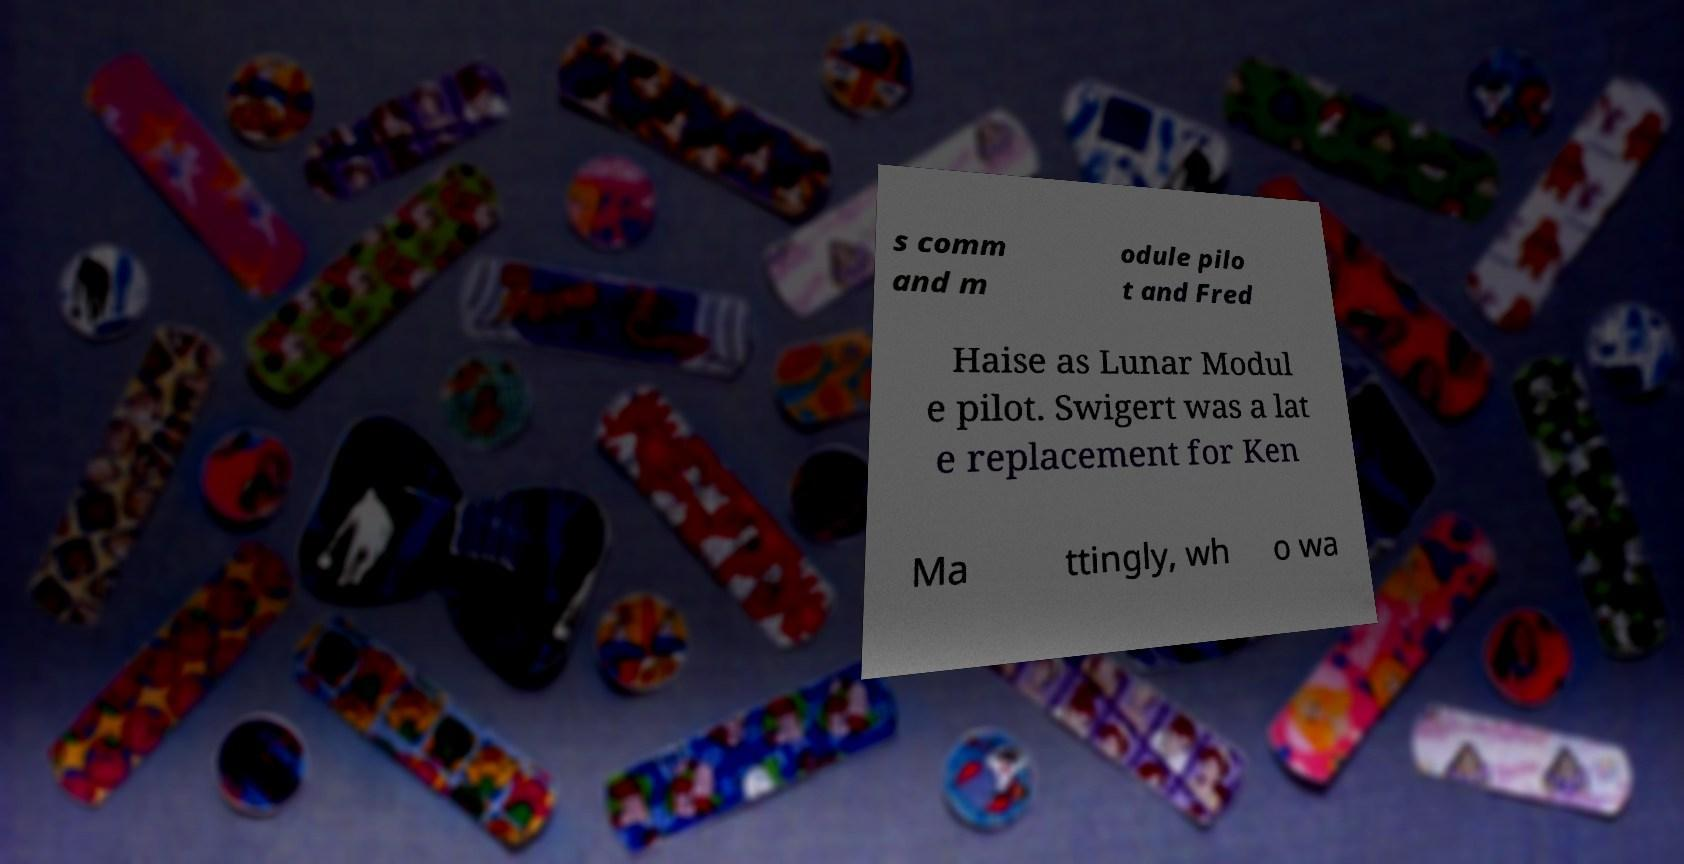Could you extract and type out the text from this image? s comm and m odule pilo t and Fred Haise as Lunar Modul e pilot. Swigert was a lat e replacement for Ken Ma ttingly, wh o wa 